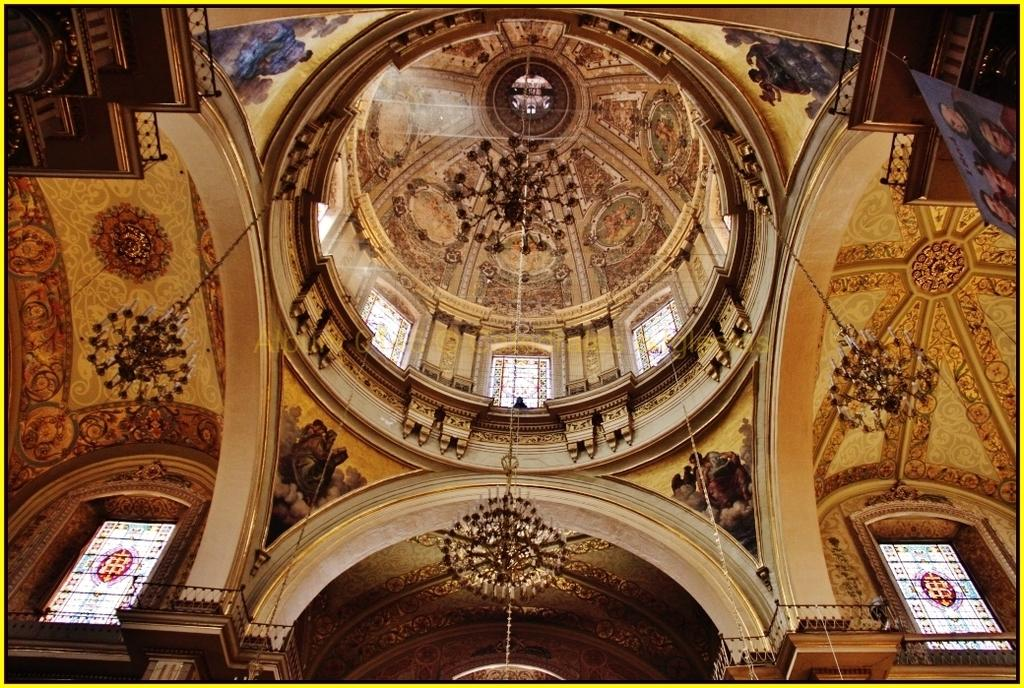What type of lighting fixture can be seen in the image? There are chandeliers in the image. What type of material is present in the image that is used for support or suspension? There are chains in the image. What type of architectural feature can be seen in the image that provides safety or guidance? There are railings in the image. What can be observed about the roof in the image? The roof in the image has a designed pattern. What allows natural light to enter the space in the image? There are windows in the image. What type of decorative items can be seen in the image? There are pictures in the image. What type of objects can be seen in the image? There are objects in the image. What type of disease can be seen affecting the chandeliers in the image? There is no disease present in the image, and the chandeliers are not affected by any disease. How many spiders can be seen crawling on the chains in the image? There are no spiders present in the image, and therefore no spiders can be seen crawling on the chains. 